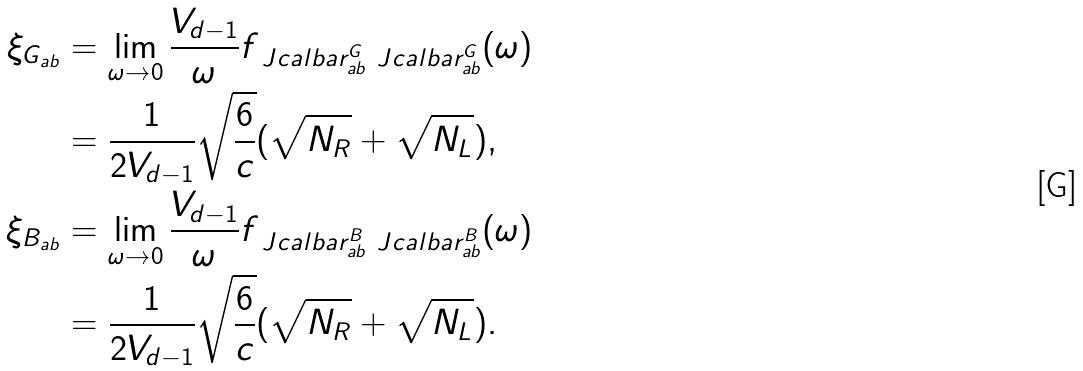Convert formula to latex. <formula><loc_0><loc_0><loc_500><loc_500>\xi _ { G _ { a b } } & = \lim _ { \omega \to 0 } \frac { V _ { d - 1 } } { \omega } f _ { \ J c a l b a r ^ { G } _ { a b } \ J c a l b a r ^ { G } _ { a b } } ( \omega ) \\ & = \frac { 1 } { 2 V _ { d - 1 } } \sqrt { \frac { 6 } { c } } ( \sqrt { N _ { R } } + \sqrt { N _ { L } } ) , \\ \xi _ { B _ { a b } } & = \lim _ { \omega \to 0 } \frac { V _ { d - 1 } } { \omega } f _ { \ J c a l b a r ^ { B } _ { a b } \ J c a l b a r ^ { B } _ { a b } } ( \omega ) \\ & = \frac { 1 } { 2 V _ { d - 1 } } \sqrt { \frac { 6 } { c } } ( \sqrt { N _ { R } } + \sqrt { N _ { L } } ) .</formula> 